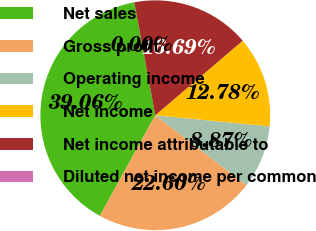Convert chart to OTSL. <chart><loc_0><loc_0><loc_500><loc_500><pie_chart><fcel>Net sales<fcel>Gross profit<fcel>Operating income<fcel>Net income<fcel>Net income attributable to<fcel>Diluted net income per common<nl><fcel>39.06%<fcel>22.6%<fcel>8.87%<fcel>12.78%<fcel>16.69%<fcel>0.0%<nl></chart> 